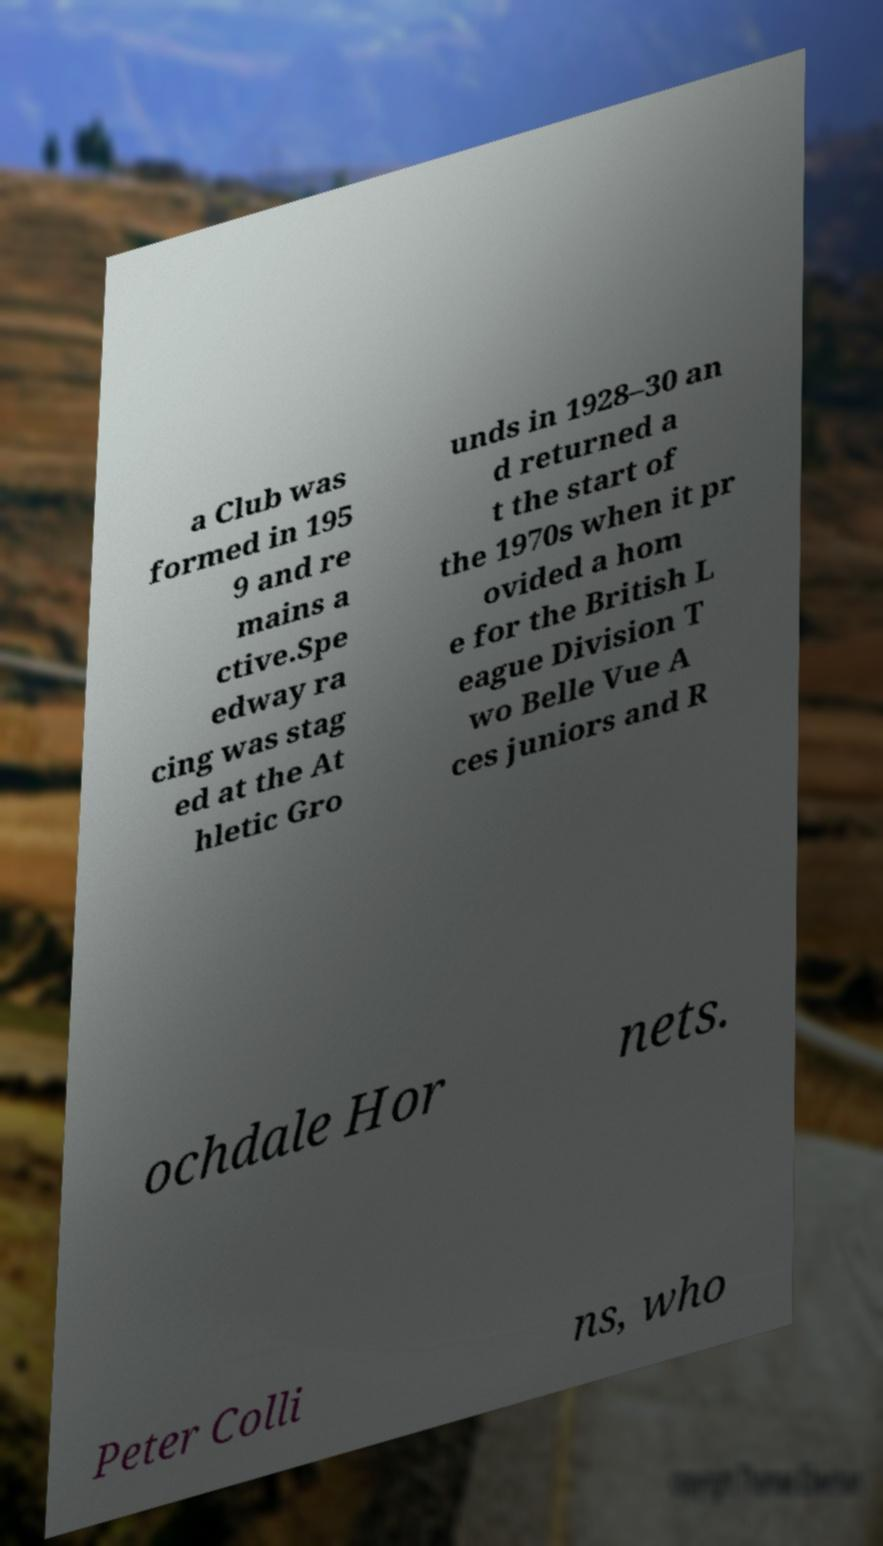Could you assist in decoding the text presented in this image and type it out clearly? a Club was formed in 195 9 and re mains a ctive.Spe edway ra cing was stag ed at the At hletic Gro unds in 1928–30 an d returned a t the start of the 1970s when it pr ovided a hom e for the British L eague Division T wo Belle Vue A ces juniors and R ochdale Hor nets. Peter Colli ns, who 